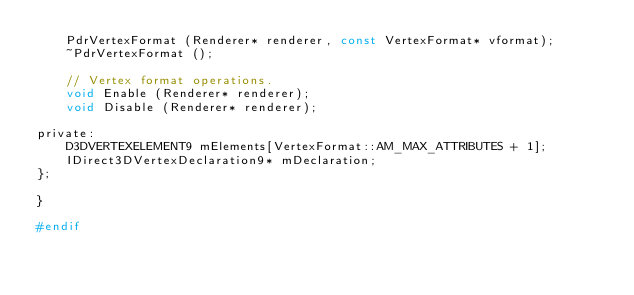Convert code to text. <code><loc_0><loc_0><loc_500><loc_500><_C_>    PdrVertexFormat (Renderer* renderer, const VertexFormat* vformat);
    ~PdrVertexFormat ();

    // Vertex format operations.
    void Enable (Renderer* renderer);
    void Disable (Renderer* renderer);

private:
    D3DVERTEXELEMENT9 mElements[VertexFormat::AM_MAX_ATTRIBUTES + 1];
    IDirect3DVertexDeclaration9* mDeclaration;
};

}

#endif
</code> 